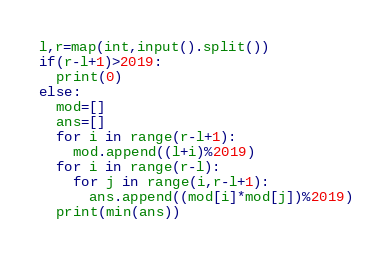<code> <loc_0><loc_0><loc_500><loc_500><_Python_>l,r=map(int,input().split())
if(r-l+1)>2019:
  print(0)
else:
  mod=[]
  ans=[]
  for i in range(r-l+1):
    mod.append((l+i)%2019)
  for i in range(r-l):
    for j in range(i,r-l+1):
      ans.append((mod[i]*mod[j])%2019)
  print(min(ans))</code> 